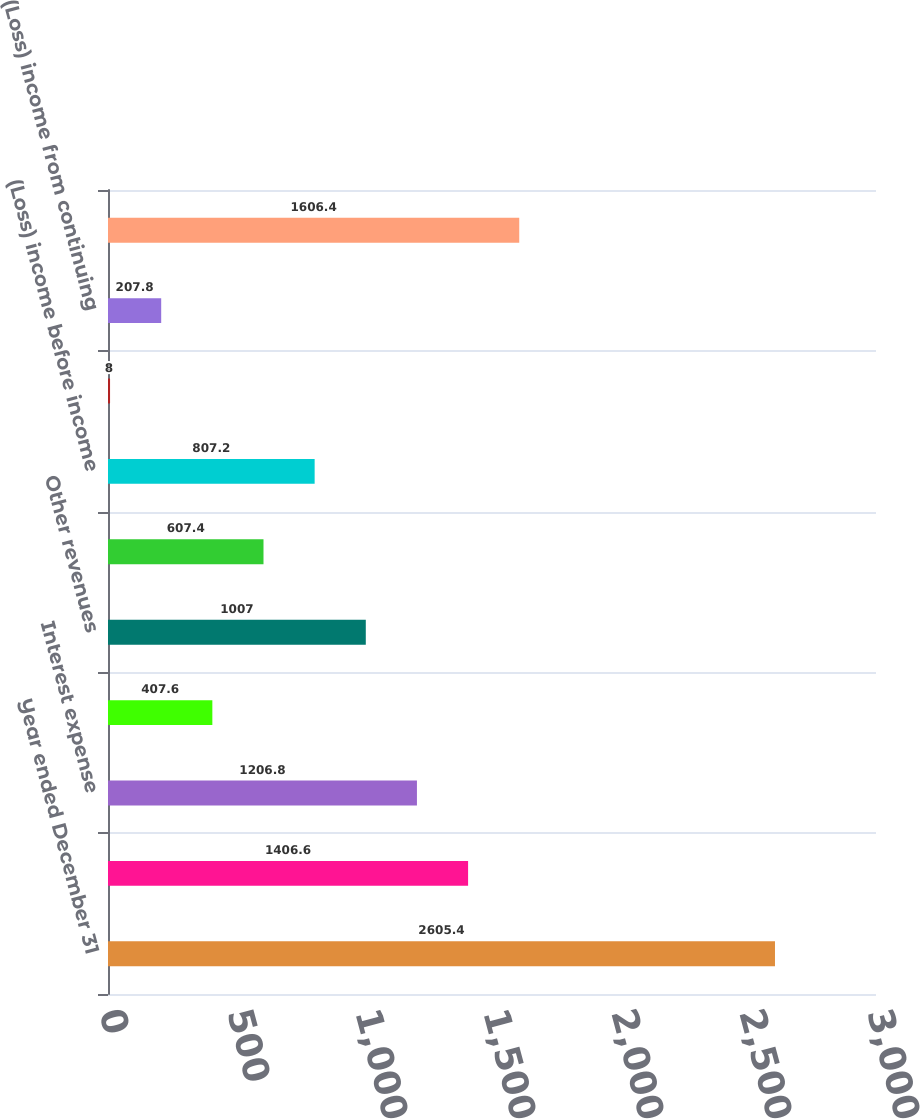Convert chart. <chart><loc_0><loc_0><loc_500><loc_500><bar_chart><fcel>Year ended December 31<fcel>Interest revenue<fcel>Interest expense<fcel>Net interest revenue<fcel>Other revenues<fcel>Other expenses<fcel>(Loss) income before income<fcel>Income tax benefit (expense)<fcel>(Loss) income from continuing<fcel>Equity in undistributed<nl><fcel>2605.4<fcel>1406.6<fcel>1206.8<fcel>407.6<fcel>1007<fcel>607.4<fcel>807.2<fcel>8<fcel>207.8<fcel>1606.4<nl></chart> 